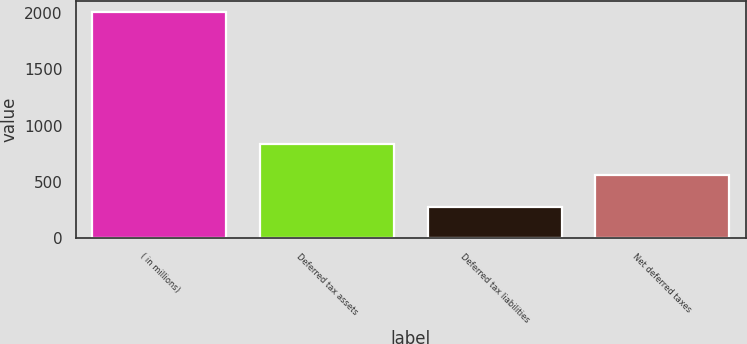Convert chart to OTSL. <chart><loc_0><loc_0><loc_500><loc_500><bar_chart><fcel>( in millions)<fcel>Deferred tax assets<fcel>Deferred tax liabilities<fcel>Net deferred taxes<nl><fcel>2004<fcel>834<fcel>275<fcel>559<nl></chart> 